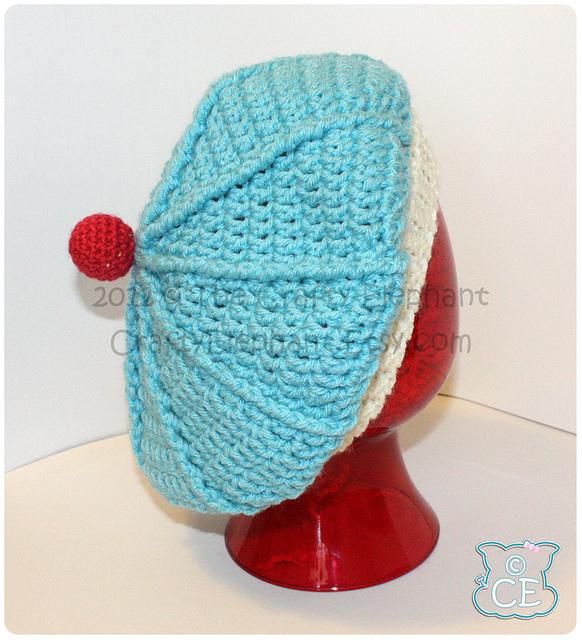What colors are in the pic?
Answer briefly. Blue and red and white. Is the hat on someone's head?
Concise answer only. No. How many animals are in the picture?
Write a very short answer. 0. 